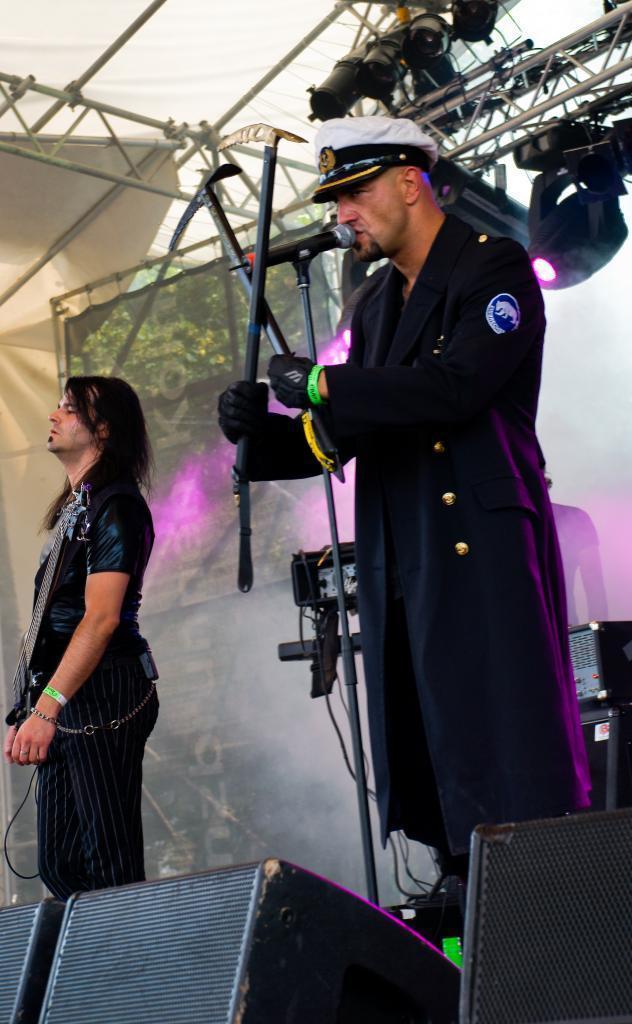Could you give a brief overview of what you see in this image? It looks like some concert there are two people in the front and around them there are many musical equipment and behind them on the top there are purple lights focusing on them. 